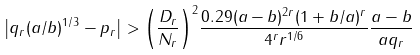<formula> <loc_0><loc_0><loc_500><loc_500>\left | q _ { r } ( a / b ) ^ { 1 / 3 } - p _ { r } \right | > { \left ( \frac { D _ { r } } { N _ { r } } \right ) } ^ { 2 } \frac { 0 . 2 9 ( a - b ) ^ { 2 r } ( 1 + b / a ) ^ { r } } { 4 ^ { r } r ^ { 1 / 6 } } \frac { a - b } { a q _ { r } }</formula> 